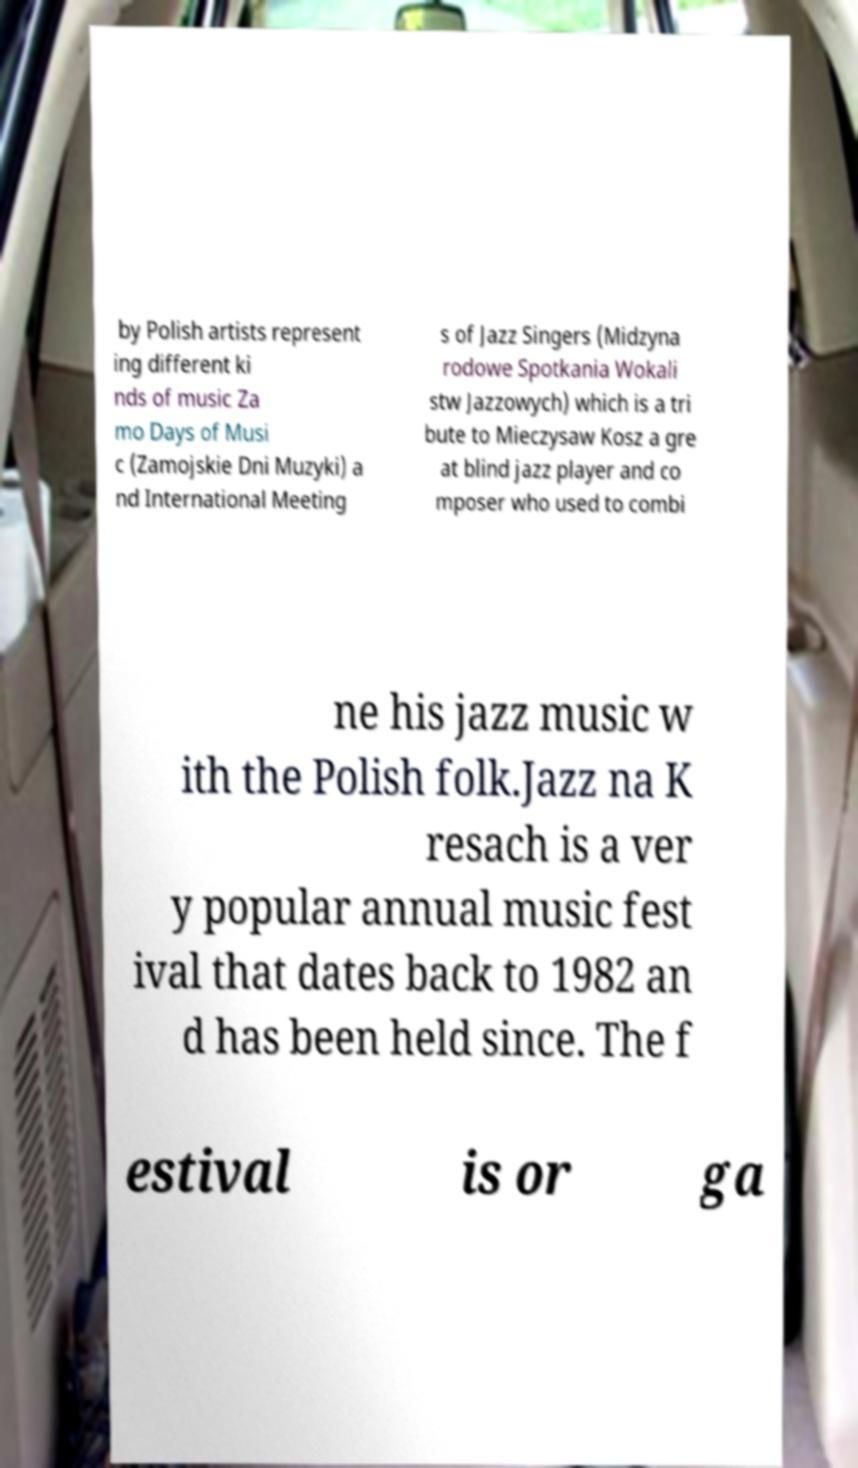For documentation purposes, I need the text within this image transcribed. Could you provide that? by Polish artists represent ing different ki nds of music Za mo Days of Musi c (Zamojskie Dni Muzyki) a nd International Meeting s of Jazz Singers (Midzyna rodowe Spotkania Wokali stw Jazzowych) which is a tri bute to Mieczysaw Kosz a gre at blind jazz player and co mposer who used to combi ne his jazz music w ith the Polish folk.Jazz na K resach is a ver y popular annual music fest ival that dates back to 1982 an d has been held since. The f estival is or ga 